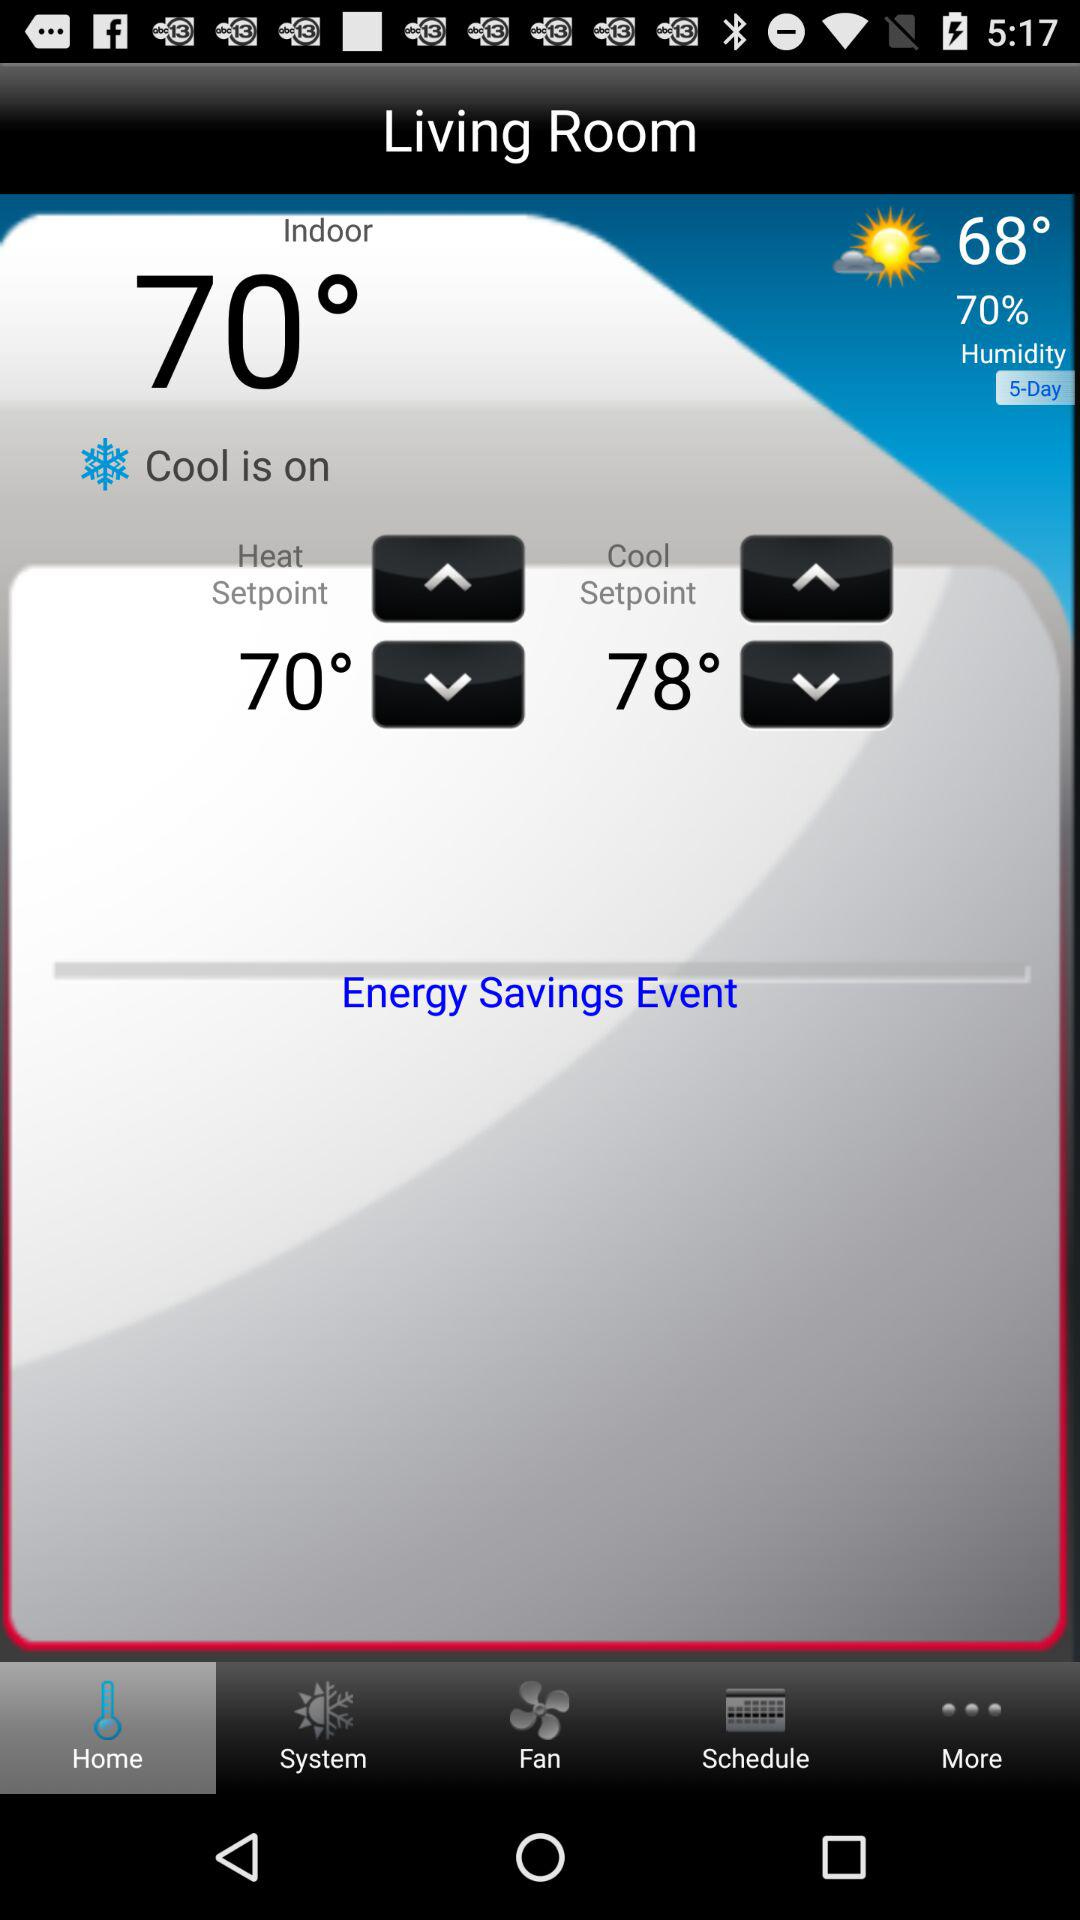What is the "Heat Setpoint"? The "Heat Setpoint" is 70°. 